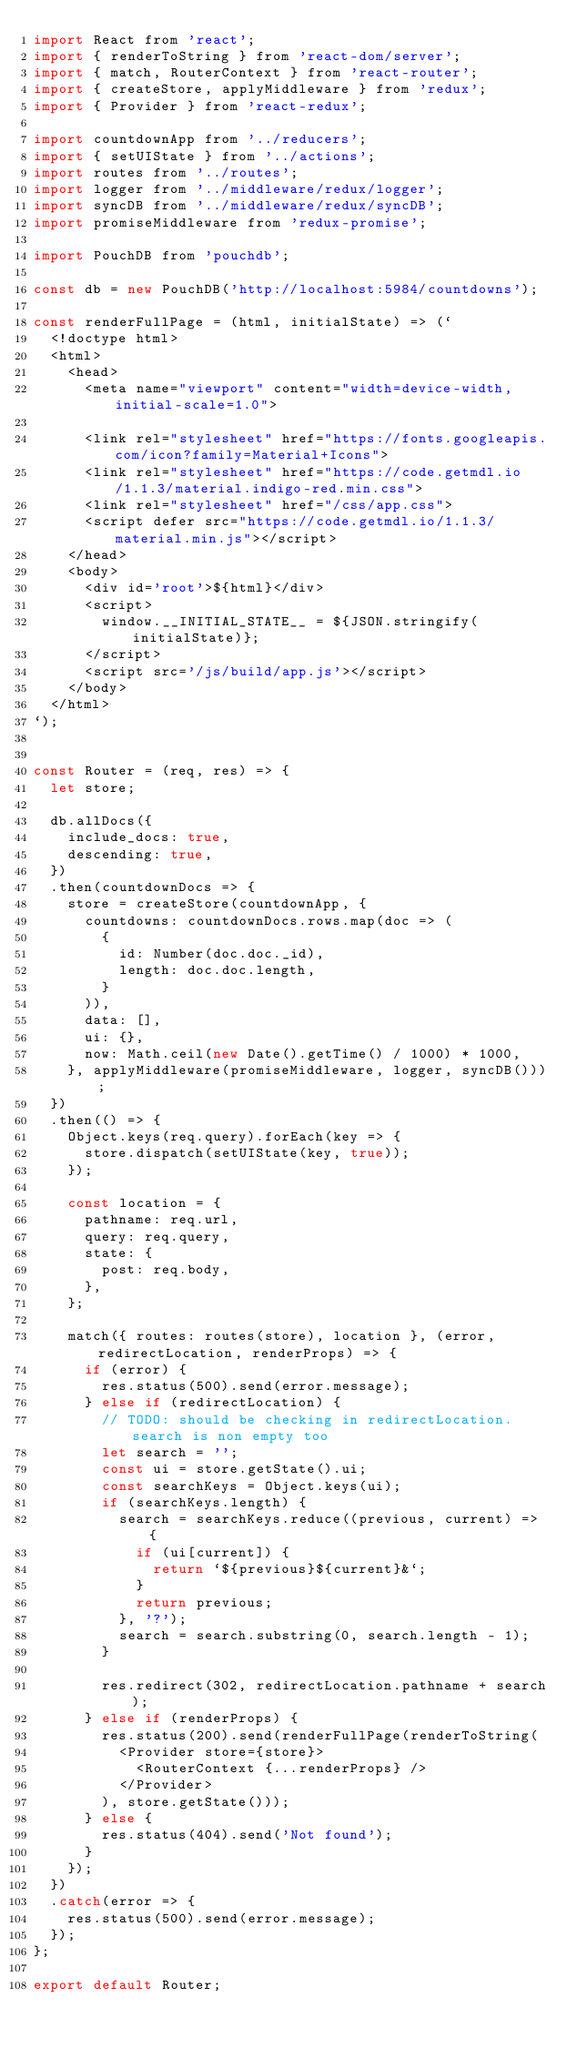Convert code to text. <code><loc_0><loc_0><loc_500><loc_500><_JavaScript_>import React from 'react';
import { renderToString } from 'react-dom/server';
import { match, RouterContext } from 'react-router';
import { createStore, applyMiddleware } from 'redux';
import { Provider } from 'react-redux';

import countdownApp from '../reducers';
import { setUIState } from '../actions';
import routes from '../routes';
import logger from '../middleware/redux/logger';
import syncDB from '../middleware/redux/syncDB';
import promiseMiddleware from 'redux-promise';

import PouchDB from 'pouchdb';

const db = new PouchDB('http://localhost:5984/countdowns');

const renderFullPage = (html, initialState) => (`
  <!doctype html>
  <html>
    <head>
      <meta name="viewport" content="width=device-width, initial-scale=1.0">

      <link rel="stylesheet" href="https://fonts.googleapis.com/icon?family=Material+Icons">
      <link rel="stylesheet" href="https://code.getmdl.io/1.1.3/material.indigo-red.min.css">
      <link rel="stylesheet" href="/css/app.css">
      <script defer src="https://code.getmdl.io/1.1.3/material.min.js"></script>
    </head>
    <body>
      <div id='root'>${html}</div>
      <script>
        window.__INITIAL_STATE__ = ${JSON.stringify(initialState)};
      </script>
      <script src='/js/build/app.js'></script>
    </body>
  </html>
`);


const Router = (req, res) => {
  let store;

  db.allDocs({
    include_docs: true,
    descending: true,
  })
  .then(countdownDocs => {
    store = createStore(countdownApp, {
      countdowns: countdownDocs.rows.map(doc => (
        {
          id: Number(doc.doc._id),
          length: doc.doc.length,
        }
      )),
      data: [],
      ui: {},
      now: Math.ceil(new Date().getTime() / 1000) * 1000,
    }, applyMiddleware(promiseMiddleware, logger, syncDB()));
  })
  .then(() => {
    Object.keys(req.query).forEach(key => {
      store.dispatch(setUIState(key, true));
    });

    const location = {
      pathname: req.url,
      query: req.query,
      state: {
        post: req.body,
      },
    };

    match({ routes: routes(store), location }, (error, redirectLocation, renderProps) => {
      if (error) {
        res.status(500).send(error.message);
      } else if (redirectLocation) {
        // TODO: should be checking in redirectLocation.search is non empty too
        let search = '';
        const ui = store.getState().ui;
        const searchKeys = Object.keys(ui);
        if (searchKeys.length) {
          search = searchKeys.reduce((previous, current) => {
            if (ui[current]) {
              return `${previous}${current}&`;
            }
            return previous;
          }, '?');
          search = search.substring(0, search.length - 1);
        }

        res.redirect(302, redirectLocation.pathname + search);
      } else if (renderProps) {
        res.status(200).send(renderFullPage(renderToString(
          <Provider store={store}>
            <RouterContext {...renderProps} />
          </Provider>
        ), store.getState()));
      } else {
        res.status(404).send('Not found');
      }
    });
  })
  .catch(error => {
    res.status(500).send(error.message);
  });
};

export default Router;
</code> 